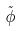Convert formula to latex. <formula><loc_0><loc_0><loc_500><loc_500>\tilde { \phi }</formula> 